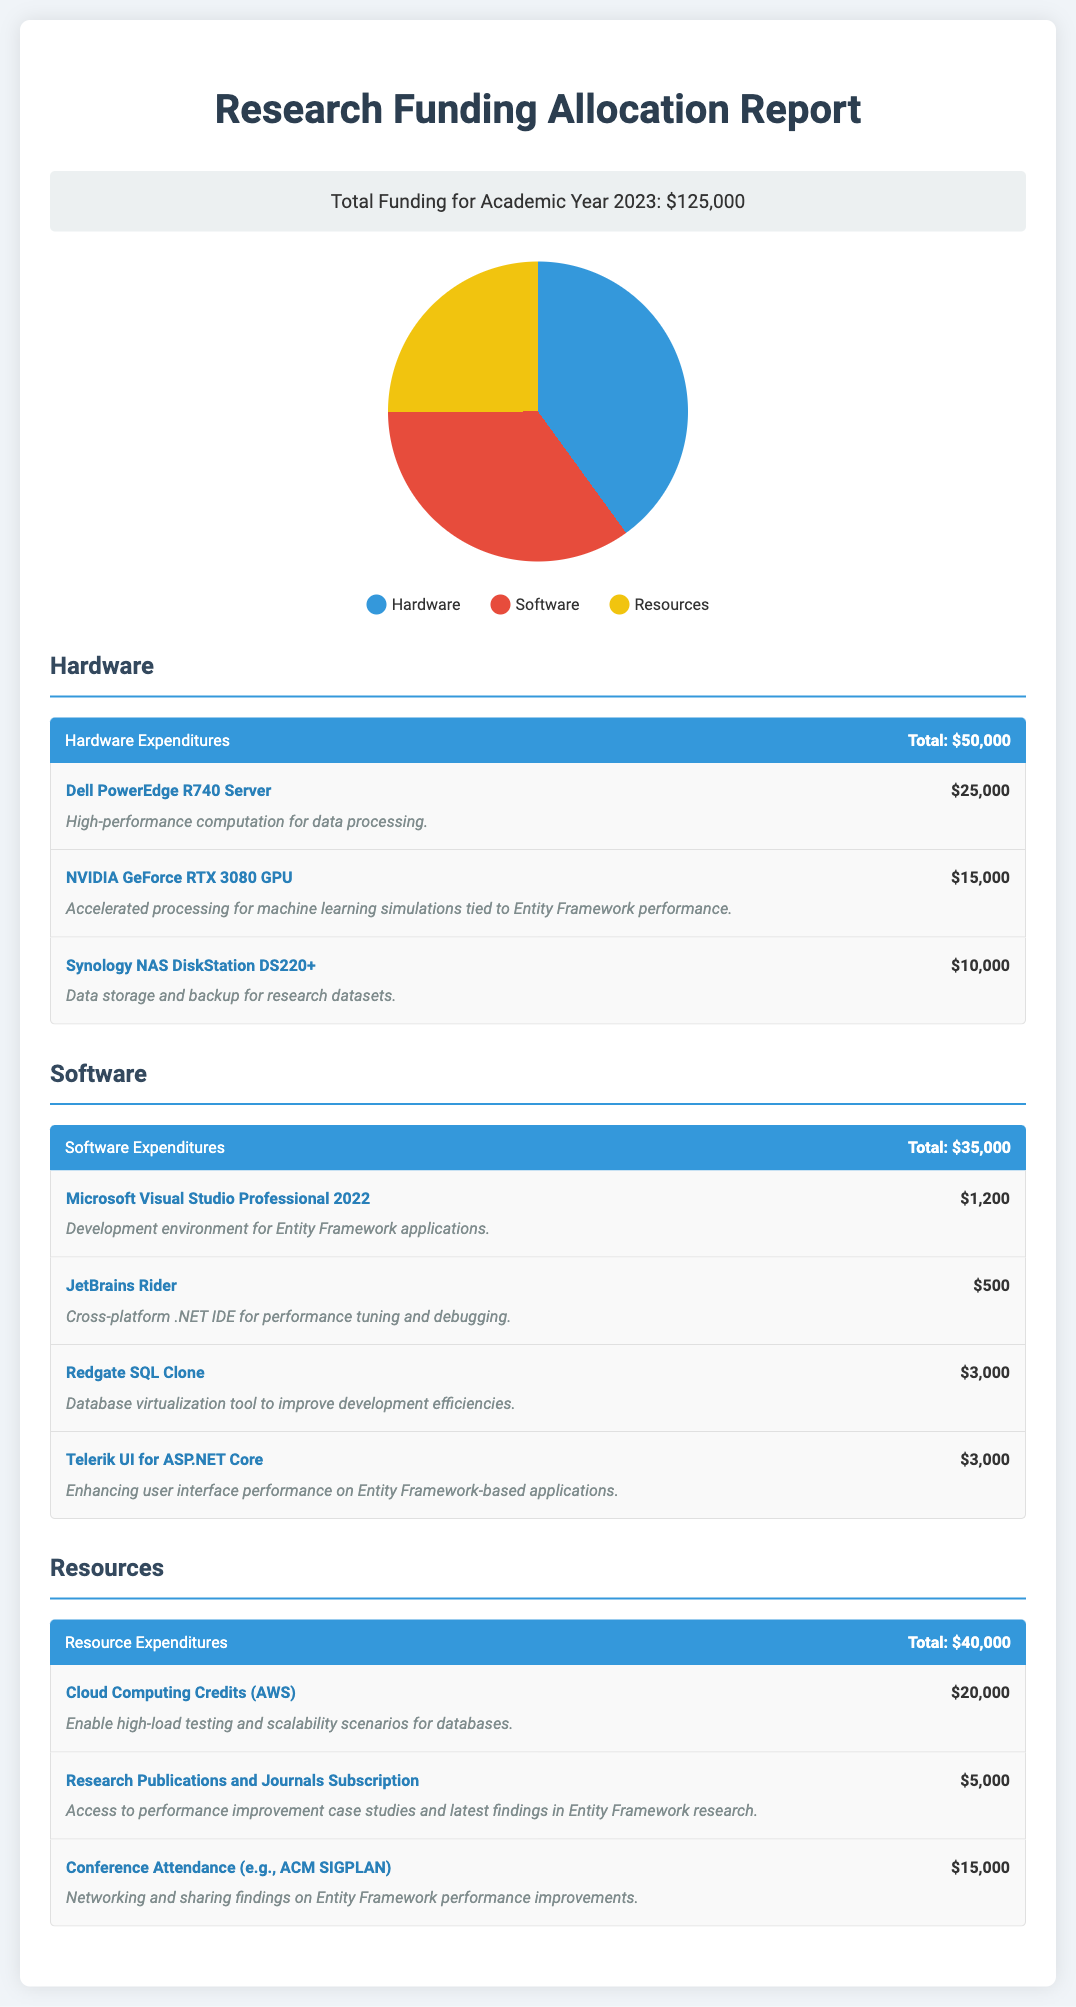What is the total funding for the academic year 2023? The total funding is listed in the report and amounts to $125,000.
Answer: $125,000 What is the total expenditure on hardware? The report details the total expenditure on hardware as $50,000.
Answer: $50,000 Which server is purchased for high-performance computation? The document specifies that the Dell PowerEdge R740 Server is purchased for high-performance computation.
Answer: Dell PowerEdge R740 Server How much was allocated for cloud computing credits? The funding report states that $20,000 was allocated for cloud computing credits.
Answer: $20,000 What software is used for development in Entity Framework applications? Microsoft Visual Studio Professional 2022 is identified as the software used for development in Entity Framework applications.
Answer: Microsoft Visual Studio Professional 2022 What percentage of the total funding is allocated for resources? The total resource expenditure is $40,000, making it 32% of the total funding ($40,000 ÷ $125,000 × 100).
Answer: 32% How much is allocated for conference attendance? The report specifies that $15,000 is allocated for conference attendance.
Answer: $15,000 Which item has the highest expenditure in hardware? The document indicates that the highest expenditure in hardware is for the Dell PowerEdge R740 Server at $25,000.
Answer: Dell PowerEdge R740 Server What is the purpose of the Redgate SQL Clone? The report describes the purpose of Redgate SQL Clone as a database virtualization tool to improve development efficiencies.
Answer: Database virtualization tool to improve development efficiencies 